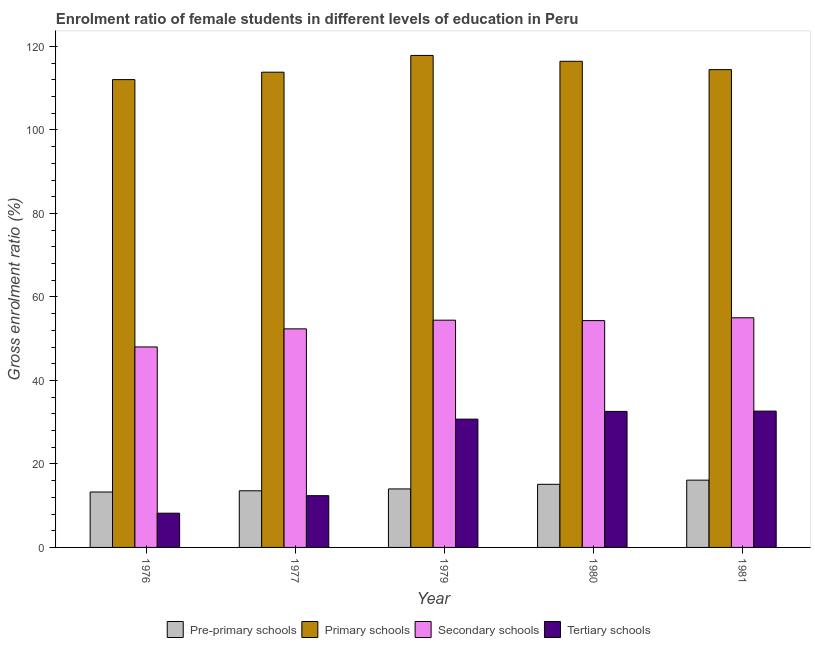How many different coloured bars are there?
Offer a terse response. 4. How many bars are there on the 4th tick from the left?
Provide a succinct answer. 4. What is the label of the 3rd group of bars from the left?
Offer a terse response. 1979. In how many cases, is the number of bars for a given year not equal to the number of legend labels?
Provide a short and direct response. 0. What is the gross enrolment ratio(male) in pre-primary schools in 1980?
Your response must be concise. 15.12. Across all years, what is the maximum gross enrolment ratio(male) in tertiary schools?
Offer a terse response. 32.65. Across all years, what is the minimum gross enrolment ratio(male) in secondary schools?
Your answer should be very brief. 48.02. In which year was the gross enrolment ratio(male) in tertiary schools maximum?
Offer a terse response. 1981. In which year was the gross enrolment ratio(male) in secondary schools minimum?
Make the answer very short. 1976. What is the total gross enrolment ratio(male) in secondary schools in the graph?
Provide a succinct answer. 264.13. What is the difference between the gross enrolment ratio(male) in secondary schools in 1979 and that in 1980?
Ensure brevity in your answer.  0.1. What is the difference between the gross enrolment ratio(male) in secondary schools in 1976 and the gross enrolment ratio(male) in primary schools in 1980?
Your answer should be compact. -6.31. What is the average gross enrolment ratio(male) in pre-primary schools per year?
Offer a terse response. 14.42. In the year 1976, what is the difference between the gross enrolment ratio(male) in tertiary schools and gross enrolment ratio(male) in pre-primary schools?
Give a very brief answer. 0. What is the ratio of the gross enrolment ratio(male) in primary schools in 1976 to that in 1980?
Offer a terse response. 0.96. Is the gross enrolment ratio(male) in primary schools in 1976 less than that in 1981?
Provide a short and direct response. Yes. Is the difference between the gross enrolment ratio(male) in pre-primary schools in 1979 and 1980 greater than the difference between the gross enrolment ratio(male) in secondary schools in 1979 and 1980?
Make the answer very short. No. What is the difference between the highest and the second highest gross enrolment ratio(male) in secondary schools?
Make the answer very short. 0.57. What is the difference between the highest and the lowest gross enrolment ratio(male) in secondary schools?
Offer a terse response. 6.98. Is it the case that in every year, the sum of the gross enrolment ratio(male) in tertiary schools and gross enrolment ratio(male) in pre-primary schools is greater than the sum of gross enrolment ratio(male) in secondary schools and gross enrolment ratio(male) in primary schools?
Ensure brevity in your answer.  No. What does the 1st bar from the left in 1979 represents?
Your answer should be compact. Pre-primary schools. What does the 3rd bar from the right in 1977 represents?
Your answer should be compact. Primary schools. Is it the case that in every year, the sum of the gross enrolment ratio(male) in pre-primary schools and gross enrolment ratio(male) in primary schools is greater than the gross enrolment ratio(male) in secondary schools?
Your response must be concise. Yes. How many bars are there?
Keep it short and to the point. 20. Are all the bars in the graph horizontal?
Make the answer very short. No. What is the difference between two consecutive major ticks on the Y-axis?
Offer a terse response. 20. Does the graph contain any zero values?
Give a very brief answer. No. What is the title of the graph?
Ensure brevity in your answer.  Enrolment ratio of female students in different levels of education in Peru. What is the label or title of the X-axis?
Your answer should be very brief. Year. What is the Gross enrolment ratio (%) in Pre-primary schools in 1976?
Provide a succinct answer. 13.27. What is the Gross enrolment ratio (%) in Primary schools in 1976?
Ensure brevity in your answer.  112.05. What is the Gross enrolment ratio (%) in Secondary schools in 1976?
Offer a very short reply. 48.02. What is the Gross enrolment ratio (%) in Tertiary schools in 1976?
Offer a very short reply. 8.2. What is the Gross enrolment ratio (%) of Pre-primary schools in 1977?
Offer a very short reply. 13.57. What is the Gross enrolment ratio (%) in Primary schools in 1977?
Provide a succinct answer. 113.82. What is the Gross enrolment ratio (%) of Secondary schools in 1977?
Ensure brevity in your answer.  52.35. What is the Gross enrolment ratio (%) in Tertiary schools in 1977?
Ensure brevity in your answer.  12.4. What is the Gross enrolment ratio (%) of Pre-primary schools in 1979?
Ensure brevity in your answer.  14.01. What is the Gross enrolment ratio (%) of Primary schools in 1979?
Your answer should be very brief. 117.84. What is the Gross enrolment ratio (%) of Secondary schools in 1979?
Keep it short and to the point. 54.43. What is the Gross enrolment ratio (%) in Tertiary schools in 1979?
Offer a very short reply. 30.73. What is the Gross enrolment ratio (%) in Pre-primary schools in 1980?
Offer a very short reply. 15.12. What is the Gross enrolment ratio (%) in Primary schools in 1980?
Provide a short and direct response. 116.44. What is the Gross enrolment ratio (%) of Secondary schools in 1980?
Your answer should be compact. 54.33. What is the Gross enrolment ratio (%) in Tertiary schools in 1980?
Offer a very short reply. 32.58. What is the Gross enrolment ratio (%) in Pre-primary schools in 1981?
Keep it short and to the point. 16.11. What is the Gross enrolment ratio (%) in Primary schools in 1981?
Your answer should be compact. 114.44. What is the Gross enrolment ratio (%) of Secondary schools in 1981?
Your answer should be compact. 55. What is the Gross enrolment ratio (%) of Tertiary schools in 1981?
Offer a very short reply. 32.65. Across all years, what is the maximum Gross enrolment ratio (%) of Pre-primary schools?
Offer a very short reply. 16.11. Across all years, what is the maximum Gross enrolment ratio (%) in Primary schools?
Your answer should be very brief. 117.84. Across all years, what is the maximum Gross enrolment ratio (%) in Secondary schools?
Ensure brevity in your answer.  55. Across all years, what is the maximum Gross enrolment ratio (%) of Tertiary schools?
Provide a succinct answer. 32.65. Across all years, what is the minimum Gross enrolment ratio (%) in Pre-primary schools?
Ensure brevity in your answer.  13.27. Across all years, what is the minimum Gross enrolment ratio (%) in Primary schools?
Make the answer very short. 112.05. Across all years, what is the minimum Gross enrolment ratio (%) in Secondary schools?
Provide a succinct answer. 48.02. Across all years, what is the minimum Gross enrolment ratio (%) of Tertiary schools?
Make the answer very short. 8.2. What is the total Gross enrolment ratio (%) of Pre-primary schools in the graph?
Your answer should be compact. 72.08. What is the total Gross enrolment ratio (%) in Primary schools in the graph?
Ensure brevity in your answer.  574.59. What is the total Gross enrolment ratio (%) of Secondary schools in the graph?
Your response must be concise. 264.13. What is the total Gross enrolment ratio (%) in Tertiary schools in the graph?
Give a very brief answer. 116.55. What is the difference between the Gross enrolment ratio (%) in Pre-primary schools in 1976 and that in 1977?
Your answer should be very brief. -0.29. What is the difference between the Gross enrolment ratio (%) of Primary schools in 1976 and that in 1977?
Offer a very short reply. -1.77. What is the difference between the Gross enrolment ratio (%) in Secondary schools in 1976 and that in 1977?
Your answer should be compact. -4.33. What is the difference between the Gross enrolment ratio (%) in Tertiary schools in 1976 and that in 1977?
Provide a succinct answer. -4.2. What is the difference between the Gross enrolment ratio (%) of Pre-primary schools in 1976 and that in 1979?
Your answer should be compact. -0.74. What is the difference between the Gross enrolment ratio (%) in Primary schools in 1976 and that in 1979?
Give a very brief answer. -5.79. What is the difference between the Gross enrolment ratio (%) of Secondary schools in 1976 and that in 1979?
Give a very brief answer. -6.41. What is the difference between the Gross enrolment ratio (%) of Tertiary schools in 1976 and that in 1979?
Your response must be concise. -22.53. What is the difference between the Gross enrolment ratio (%) in Pre-primary schools in 1976 and that in 1980?
Your response must be concise. -1.85. What is the difference between the Gross enrolment ratio (%) of Primary schools in 1976 and that in 1980?
Your answer should be very brief. -4.39. What is the difference between the Gross enrolment ratio (%) in Secondary schools in 1976 and that in 1980?
Your response must be concise. -6.31. What is the difference between the Gross enrolment ratio (%) of Tertiary schools in 1976 and that in 1980?
Give a very brief answer. -24.38. What is the difference between the Gross enrolment ratio (%) of Pre-primary schools in 1976 and that in 1981?
Offer a terse response. -2.84. What is the difference between the Gross enrolment ratio (%) of Primary schools in 1976 and that in 1981?
Ensure brevity in your answer.  -2.39. What is the difference between the Gross enrolment ratio (%) in Secondary schools in 1976 and that in 1981?
Keep it short and to the point. -6.98. What is the difference between the Gross enrolment ratio (%) in Tertiary schools in 1976 and that in 1981?
Ensure brevity in your answer.  -24.45. What is the difference between the Gross enrolment ratio (%) in Pre-primary schools in 1977 and that in 1979?
Provide a succinct answer. -0.44. What is the difference between the Gross enrolment ratio (%) of Primary schools in 1977 and that in 1979?
Provide a short and direct response. -4.02. What is the difference between the Gross enrolment ratio (%) of Secondary schools in 1977 and that in 1979?
Your answer should be very brief. -2.08. What is the difference between the Gross enrolment ratio (%) in Tertiary schools in 1977 and that in 1979?
Your answer should be compact. -18.33. What is the difference between the Gross enrolment ratio (%) of Pre-primary schools in 1977 and that in 1980?
Make the answer very short. -1.55. What is the difference between the Gross enrolment ratio (%) of Primary schools in 1977 and that in 1980?
Give a very brief answer. -2.61. What is the difference between the Gross enrolment ratio (%) of Secondary schools in 1977 and that in 1980?
Provide a short and direct response. -1.97. What is the difference between the Gross enrolment ratio (%) of Tertiary schools in 1977 and that in 1980?
Your answer should be very brief. -20.18. What is the difference between the Gross enrolment ratio (%) of Pre-primary schools in 1977 and that in 1981?
Give a very brief answer. -2.55. What is the difference between the Gross enrolment ratio (%) of Primary schools in 1977 and that in 1981?
Provide a succinct answer. -0.62. What is the difference between the Gross enrolment ratio (%) of Secondary schools in 1977 and that in 1981?
Your response must be concise. -2.65. What is the difference between the Gross enrolment ratio (%) of Tertiary schools in 1977 and that in 1981?
Offer a very short reply. -20.25. What is the difference between the Gross enrolment ratio (%) in Pre-primary schools in 1979 and that in 1980?
Your answer should be compact. -1.11. What is the difference between the Gross enrolment ratio (%) in Primary schools in 1979 and that in 1980?
Your answer should be compact. 1.4. What is the difference between the Gross enrolment ratio (%) in Secondary schools in 1979 and that in 1980?
Offer a terse response. 0.1. What is the difference between the Gross enrolment ratio (%) in Tertiary schools in 1979 and that in 1980?
Provide a short and direct response. -1.85. What is the difference between the Gross enrolment ratio (%) in Pre-primary schools in 1979 and that in 1981?
Make the answer very short. -2.1. What is the difference between the Gross enrolment ratio (%) of Primary schools in 1979 and that in 1981?
Provide a short and direct response. 3.4. What is the difference between the Gross enrolment ratio (%) of Secondary schools in 1979 and that in 1981?
Offer a very short reply. -0.57. What is the difference between the Gross enrolment ratio (%) of Tertiary schools in 1979 and that in 1981?
Keep it short and to the point. -1.92. What is the difference between the Gross enrolment ratio (%) of Pre-primary schools in 1980 and that in 1981?
Offer a very short reply. -1. What is the difference between the Gross enrolment ratio (%) in Primary schools in 1980 and that in 1981?
Offer a terse response. 2. What is the difference between the Gross enrolment ratio (%) in Secondary schools in 1980 and that in 1981?
Your response must be concise. -0.67. What is the difference between the Gross enrolment ratio (%) in Tertiary schools in 1980 and that in 1981?
Offer a terse response. -0.07. What is the difference between the Gross enrolment ratio (%) in Pre-primary schools in 1976 and the Gross enrolment ratio (%) in Primary schools in 1977?
Your answer should be compact. -100.55. What is the difference between the Gross enrolment ratio (%) in Pre-primary schools in 1976 and the Gross enrolment ratio (%) in Secondary schools in 1977?
Offer a terse response. -39.08. What is the difference between the Gross enrolment ratio (%) of Pre-primary schools in 1976 and the Gross enrolment ratio (%) of Tertiary schools in 1977?
Keep it short and to the point. 0.88. What is the difference between the Gross enrolment ratio (%) of Primary schools in 1976 and the Gross enrolment ratio (%) of Secondary schools in 1977?
Make the answer very short. 59.7. What is the difference between the Gross enrolment ratio (%) of Primary schools in 1976 and the Gross enrolment ratio (%) of Tertiary schools in 1977?
Your response must be concise. 99.65. What is the difference between the Gross enrolment ratio (%) of Secondary schools in 1976 and the Gross enrolment ratio (%) of Tertiary schools in 1977?
Your answer should be very brief. 35.62. What is the difference between the Gross enrolment ratio (%) in Pre-primary schools in 1976 and the Gross enrolment ratio (%) in Primary schools in 1979?
Offer a terse response. -104.57. What is the difference between the Gross enrolment ratio (%) in Pre-primary schools in 1976 and the Gross enrolment ratio (%) in Secondary schools in 1979?
Keep it short and to the point. -41.16. What is the difference between the Gross enrolment ratio (%) in Pre-primary schools in 1976 and the Gross enrolment ratio (%) in Tertiary schools in 1979?
Give a very brief answer. -17.45. What is the difference between the Gross enrolment ratio (%) in Primary schools in 1976 and the Gross enrolment ratio (%) in Secondary schools in 1979?
Keep it short and to the point. 57.62. What is the difference between the Gross enrolment ratio (%) in Primary schools in 1976 and the Gross enrolment ratio (%) in Tertiary schools in 1979?
Offer a terse response. 81.32. What is the difference between the Gross enrolment ratio (%) of Secondary schools in 1976 and the Gross enrolment ratio (%) of Tertiary schools in 1979?
Offer a terse response. 17.3. What is the difference between the Gross enrolment ratio (%) of Pre-primary schools in 1976 and the Gross enrolment ratio (%) of Primary schools in 1980?
Your answer should be very brief. -103.16. What is the difference between the Gross enrolment ratio (%) of Pre-primary schools in 1976 and the Gross enrolment ratio (%) of Secondary schools in 1980?
Offer a very short reply. -41.05. What is the difference between the Gross enrolment ratio (%) of Pre-primary schools in 1976 and the Gross enrolment ratio (%) of Tertiary schools in 1980?
Your answer should be compact. -19.3. What is the difference between the Gross enrolment ratio (%) of Primary schools in 1976 and the Gross enrolment ratio (%) of Secondary schools in 1980?
Provide a short and direct response. 57.72. What is the difference between the Gross enrolment ratio (%) of Primary schools in 1976 and the Gross enrolment ratio (%) of Tertiary schools in 1980?
Keep it short and to the point. 79.47. What is the difference between the Gross enrolment ratio (%) in Secondary schools in 1976 and the Gross enrolment ratio (%) in Tertiary schools in 1980?
Keep it short and to the point. 15.45. What is the difference between the Gross enrolment ratio (%) in Pre-primary schools in 1976 and the Gross enrolment ratio (%) in Primary schools in 1981?
Provide a short and direct response. -101.17. What is the difference between the Gross enrolment ratio (%) of Pre-primary schools in 1976 and the Gross enrolment ratio (%) of Secondary schools in 1981?
Offer a very short reply. -41.73. What is the difference between the Gross enrolment ratio (%) in Pre-primary schools in 1976 and the Gross enrolment ratio (%) in Tertiary schools in 1981?
Provide a short and direct response. -19.38. What is the difference between the Gross enrolment ratio (%) of Primary schools in 1976 and the Gross enrolment ratio (%) of Secondary schools in 1981?
Ensure brevity in your answer.  57.05. What is the difference between the Gross enrolment ratio (%) in Primary schools in 1976 and the Gross enrolment ratio (%) in Tertiary schools in 1981?
Offer a very short reply. 79.4. What is the difference between the Gross enrolment ratio (%) of Secondary schools in 1976 and the Gross enrolment ratio (%) of Tertiary schools in 1981?
Ensure brevity in your answer.  15.37. What is the difference between the Gross enrolment ratio (%) in Pre-primary schools in 1977 and the Gross enrolment ratio (%) in Primary schools in 1979?
Provide a short and direct response. -104.27. What is the difference between the Gross enrolment ratio (%) in Pre-primary schools in 1977 and the Gross enrolment ratio (%) in Secondary schools in 1979?
Keep it short and to the point. -40.86. What is the difference between the Gross enrolment ratio (%) in Pre-primary schools in 1977 and the Gross enrolment ratio (%) in Tertiary schools in 1979?
Give a very brief answer. -17.16. What is the difference between the Gross enrolment ratio (%) in Primary schools in 1977 and the Gross enrolment ratio (%) in Secondary schools in 1979?
Make the answer very short. 59.39. What is the difference between the Gross enrolment ratio (%) in Primary schools in 1977 and the Gross enrolment ratio (%) in Tertiary schools in 1979?
Give a very brief answer. 83.1. What is the difference between the Gross enrolment ratio (%) in Secondary schools in 1977 and the Gross enrolment ratio (%) in Tertiary schools in 1979?
Give a very brief answer. 21.63. What is the difference between the Gross enrolment ratio (%) in Pre-primary schools in 1977 and the Gross enrolment ratio (%) in Primary schools in 1980?
Offer a very short reply. -102.87. What is the difference between the Gross enrolment ratio (%) in Pre-primary schools in 1977 and the Gross enrolment ratio (%) in Secondary schools in 1980?
Your response must be concise. -40.76. What is the difference between the Gross enrolment ratio (%) of Pre-primary schools in 1977 and the Gross enrolment ratio (%) of Tertiary schools in 1980?
Offer a terse response. -19.01. What is the difference between the Gross enrolment ratio (%) of Primary schools in 1977 and the Gross enrolment ratio (%) of Secondary schools in 1980?
Provide a short and direct response. 59.5. What is the difference between the Gross enrolment ratio (%) of Primary schools in 1977 and the Gross enrolment ratio (%) of Tertiary schools in 1980?
Keep it short and to the point. 81.25. What is the difference between the Gross enrolment ratio (%) in Secondary schools in 1977 and the Gross enrolment ratio (%) in Tertiary schools in 1980?
Your answer should be compact. 19.78. What is the difference between the Gross enrolment ratio (%) of Pre-primary schools in 1977 and the Gross enrolment ratio (%) of Primary schools in 1981?
Keep it short and to the point. -100.87. What is the difference between the Gross enrolment ratio (%) in Pre-primary schools in 1977 and the Gross enrolment ratio (%) in Secondary schools in 1981?
Offer a terse response. -41.43. What is the difference between the Gross enrolment ratio (%) in Pre-primary schools in 1977 and the Gross enrolment ratio (%) in Tertiary schools in 1981?
Offer a very short reply. -19.08. What is the difference between the Gross enrolment ratio (%) in Primary schools in 1977 and the Gross enrolment ratio (%) in Secondary schools in 1981?
Keep it short and to the point. 58.82. What is the difference between the Gross enrolment ratio (%) in Primary schools in 1977 and the Gross enrolment ratio (%) in Tertiary schools in 1981?
Give a very brief answer. 81.17. What is the difference between the Gross enrolment ratio (%) of Secondary schools in 1977 and the Gross enrolment ratio (%) of Tertiary schools in 1981?
Your answer should be compact. 19.7. What is the difference between the Gross enrolment ratio (%) in Pre-primary schools in 1979 and the Gross enrolment ratio (%) in Primary schools in 1980?
Your answer should be compact. -102.43. What is the difference between the Gross enrolment ratio (%) in Pre-primary schools in 1979 and the Gross enrolment ratio (%) in Secondary schools in 1980?
Make the answer very short. -40.32. What is the difference between the Gross enrolment ratio (%) of Pre-primary schools in 1979 and the Gross enrolment ratio (%) of Tertiary schools in 1980?
Your answer should be very brief. -18.56. What is the difference between the Gross enrolment ratio (%) of Primary schools in 1979 and the Gross enrolment ratio (%) of Secondary schools in 1980?
Ensure brevity in your answer.  63.52. What is the difference between the Gross enrolment ratio (%) in Primary schools in 1979 and the Gross enrolment ratio (%) in Tertiary schools in 1980?
Offer a terse response. 85.27. What is the difference between the Gross enrolment ratio (%) of Secondary schools in 1979 and the Gross enrolment ratio (%) of Tertiary schools in 1980?
Make the answer very short. 21.85. What is the difference between the Gross enrolment ratio (%) of Pre-primary schools in 1979 and the Gross enrolment ratio (%) of Primary schools in 1981?
Ensure brevity in your answer.  -100.43. What is the difference between the Gross enrolment ratio (%) of Pre-primary schools in 1979 and the Gross enrolment ratio (%) of Secondary schools in 1981?
Provide a short and direct response. -40.99. What is the difference between the Gross enrolment ratio (%) of Pre-primary schools in 1979 and the Gross enrolment ratio (%) of Tertiary schools in 1981?
Your response must be concise. -18.64. What is the difference between the Gross enrolment ratio (%) of Primary schools in 1979 and the Gross enrolment ratio (%) of Secondary schools in 1981?
Provide a succinct answer. 62.84. What is the difference between the Gross enrolment ratio (%) of Primary schools in 1979 and the Gross enrolment ratio (%) of Tertiary schools in 1981?
Ensure brevity in your answer.  85.19. What is the difference between the Gross enrolment ratio (%) in Secondary schools in 1979 and the Gross enrolment ratio (%) in Tertiary schools in 1981?
Provide a short and direct response. 21.78. What is the difference between the Gross enrolment ratio (%) of Pre-primary schools in 1980 and the Gross enrolment ratio (%) of Primary schools in 1981?
Make the answer very short. -99.32. What is the difference between the Gross enrolment ratio (%) of Pre-primary schools in 1980 and the Gross enrolment ratio (%) of Secondary schools in 1981?
Ensure brevity in your answer.  -39.88. What is the difference between the Gross enrolment ratio (%) of Pre-primary schools in 1980 and the Gross enrolment ratio (%) of Tertiary schools in 1981?
Offer a very short reply. -17.53. What is the difference between the Gross enrolment ratio (%) in Primary schools in 1980 and the Gross enrolment ratio (%) in Secondary schools in 1981?
Provide a short and direct response. 61.44. What is the difference between the Gross enrolment ratio (%) of Primary schools in 1980 and the Gross enrolment ratio (%) of Tertiary schools in 1981?
Provide a succinct answer. 83.79. What is the difference between the Gross enrolment ratio (%) in Secondary schools in 1980 and the Gross enrolment ratio (%) in Tertiary schools in 1981?
Your answer should be very brief. 21.68. What is the average Gross enrolment ratio (%) of Pre-primary schools per year?
Provide a succinct answer. 14.42. What is the average Gross enrolment ratio (%) of Primary schools per year?
Provide a succinct answer. 114.92. What is the average Gross enrolment ratio (%) of Secondary schools per year?
Your answer should be compact. 52.83. What is the average Gross enrolment ratio (%) of Tertiary schools per year?
Provide a short and direct response. 23.31. In the year 1976, what is the difference between the Gross enrolment ratio (%) in Pre-primary schools and Gross enrolment ratio (%) in Primary schools?
Your response must be concise. -98.78. In the year 1976, what is the difference between the Gross enrolment ratio (%) in Pre-primary schools and Gross enrolment ratio (%) in Secondary schools?
Offer a terse response. -34.75. In the year 1976, what is the difference between the Gross enrolment ratio (%) in Pre-primary schools and Gross enrolment ratio (%) in Tertiary schools?
Provide a short and direct response. 5.07. In the year 1976, what is the difference between the Gross enrolment ratio (%) in Primary schools and Gross enrolment ratio (%) in Secondary schools?
Your answer should be very brief. 64.03. In the year 1976, what is the difference between the Gross enrolment ratio (%) in Primary schools and Gross enrolment ratio (%) in Tertiary schools?
Give a very brief answer. 103.85. In the year 1976, what is the difference between the Gross enrolment ratio (%) of Secondary schools and Gross enrolment ratio (%) of Tertiary schools?
Offer a terse response. 39.82. In the year 1977, what is the difference between the Gross enrolment ratio (%) in Pre-primary schools and Gross enrolment ratio (%) in Primary schools?
Your response must be concise. -100.26. In the year 1977, what is the difference between the Gross enrolment ratio (%) of Pre-primary schools and Gross enrolment ratio (%) of Secondary schools?
Your response must be concise. -38.79. In the year 1977, what is the difference between the Gross enrolment ratio (%) in Pre-primary schools and Gross enrolment ratio (%) in Tertiary schools?
Ensure brevity in your answer.  1.17. In the year 1977, what is the difference between the Gross enrolment ratio (%) in Primary schools and Gross enrolment ratio (%) in Secondary schools?
Your answer should be compact. 61.47. In the year 1977, what is the difference between the Gross enrolment ratio (%) of Primary schools and Gross enrolment ratio (%) of Tertiary schools?
Keep it short and to the point. 101.43. In the year 1977, what is the difference between the Gross enrolment ratio (%) of Secondary schools and Gross enrolment ratio (%) of Tertiary schools?
Offer a terse response. 39.96. In the year 1979, what is the difference between the Gross enrolment ratio (%) of Pre-primary schools and Gross enrolment ratio (%) of Primary schools?
Provide a succinct answer. -103.83. In the year 1979, what is the difference between the Gross enrolment ratio (%) in Pre-primary schools and Gross enrolment ratio (%) in Secondary schools?
Provide a succinct answer. -40.42. In the year 1979, what is the difference between the Gross enrolment ratio (%) of Pre-primary schools and Gross enrolment ratio (%) of Tertiary schools?
Offer a terse response. -16.72. In the year 1979, what is the difference between the Gross enrolment ratio (%) of Primary schools and Gross enrolment ratio (%) of Secondary schools?
Your answer should be compact. 63.41. In the year 1979, what is the difference between the Gross enrolment ratio (%) in Primary schools and Gross enrolment ratio (%) in Tertiary schools?
Your answer should be compact. 87.12. In the year 1979, what is the difference between the Gross enrolment ratio (%) in Secondary schools and Gross enrolment ratio (%) in Tertiary schools?
Give a very brief answer. 23.7. In the year 1980, what is the difference between the Gross enrolment ratio (%) in Pre-primary schools and Gross enrolment ratio (%) in Primary schools?
Ensure brevity in your answer.  -101.32. In the year 1980, what is the difference between the Gross enrolment ratio (%) of Pre-primary schools and Gross enrolment ratio (%) of Secondary schools?
Your response must be concise. -39.21. In the year 1980, what is the difference between the Gross enrolment ratio (%) in Pre-primary schools and Gross enrolment ratio (%) in Tertiary schools?
Provide a short and direct response. -17.46. In the year 1980, what is the difference between the Gross enrolment ratio (%) in Primary schools and Gross enrolment ratio (%) in Secondary schools?
Keep it short and to the point. 62.11. In the year 1980, what is the difference between the Gross enrolment ratio (%) of Primary schools and Gross enrolment ratio (%) of Tertiary schools?
Keep it short and to the point. 83.86. In the year 1980, what is the difference between the Gross enrolment ratio (%) of Secondary schools and Gross enrolment ratio (%) of Tertiary schools?
Provide a short and direct response. 21.75. In the year 1981, what is the difference between the Gross enrolment ratio (%) of Pre-primary schools and Gross enrolment ratio (%) of Primary schools?
Offer a very short reply. -98.33. In the year 1981, what is the difference between the Gross enrolment ratio (%) of Pre-primary schools and Gross enrolment ratio (%) of Secondary schools?
Make the answer very short. -38.89. In the year 1981, what is the difference between the Gross enrolment ratio (%) in Pre-primary schools and Gross enrolment ratio (%) in Tertiary schools?
Your answer should be compact. -16.54. In the year 1981, what is the difference between the Gross enrolment ratio (%) in Primary schools and Gross enrolment ratio (%) in Secondary schools?
Ensure brevity in your answer.  59.44. In the year 1981, what is the difference between the Gross enrolment ratio (%) in Primary schools and Gross enrolment ratio (%) in Tertiary schools?
Keep it short and to the point. 81.79. In the year 1981, what is the difference between the Gross enrolment ratio (%) in Secondary schools and Gross enrolment ratio (%) in Tertiary schools?
Ensure brevity in your answer.  22.35. What is the ratio of the Gross enrolment ratio (%) of Pre-primary schools in 1976 to that in 1977?
Your response must be concise. 0.98. What is the ratio of the Gross enrolment ratio (%) of Primary schools in 1976 to that in 1977?
Your response must be concise. 0.98. What is the ratio of the Gross enrolment ratio (%) of Secondary schools in 1976 to that in 1977?
Your answer should be very brief. 0.92. What is the ratio of the Gross enrolment ratio (%) of Tertiary schools in 1976 to that in 1977?
Your answer should be compact. 0.66. What is the ratio of the Gross enrolment ratio (%) of Pre-primary schools in 1976 to that in 1979?
Provide a succinct answer. 0.95. What is the ratio of the Gross enrolment ratio (%) of Primary schools in 1976 to that in 1979?
Ensure brevity in your answer.  0.95. What is the ratio of the Gross enrolment ratio (%) in Secondary schools in 1976 to that in 1979?
Offer a very short reply. 0.88. What is the ratio of the Gross enrolment ratio (%) in Tertiary schools in 1976 to that in 1979?
Your answer should be compact. 0.27. What is the ratio of the Gross enrolment ratio (%) in Pre-primary schools in 1976 to that in 1980?
Ensure brevity in your answer.  0.88. What is the ratio of the Gross enrolment ratio (%) in Primary schools in 1976 to that in 1980?
Offer a terse response. 0.96. What is the ratio of the Gross enrolment ratio (%) in Secondary schools in 1976 to that in 1980?
Keep it short and to the point. 0.88. What is the ratio of the Gross enrolment ratio (%) of Tertiary schools in 1976 to that in 1980?
Keep it short and to the point. 0.25. What is the ratio of the Gross enrolment ratio (%) of Pre-primary schools in 1976 to that in 1981?
Make the answer very short. 0.82. What is the ratio of the Gross enrolment ratio (%) in Primary schools in 1976 to that in 1981?
Provide a short and direct response. 0.98. What is the ratio of the Gross enrolment ratio (%) of Secondary schools in 1976 to that in 1981?
Give a very brief answer. 0.87. What is the ratio of the Gross enrolment ratio (%) of Tertiary schools in 1976 to that in 1981?
Keep it short and to the point. 0.25. What is the ratio of the Gross enrolment ratio (%) of Pre-primary schools in 1977 to that in 1979?
Give a very brief answer. 0.97. What is the ratio of the Gross enrolment ratio (%) in Primary schools in 1977 to that in 1979?
Give a very brief answer. 0.97. What is the ratio of the Gross enrolment ratio (%) in Secondary schools in 1977 to that in 1979?
Make the answer very short. 0.96. What is the ratio of the Gross enrolment ratio (%) in Tertiary schools in 1977 to that in 1979?
Offer a very short reply. 0.4. What is the ratio of the Gross enrolment ratio (%) of Pre-primary schools in 1977 to that in 1980?
Your answer should be compact. 0.9. What is the ratio of the Gross enrolment ratio (%) in Primary schools in 1977 to that in 1980?
Your answer should be very brief. 0.98. What is the ratio of the Gross enrolment ratio (%) in Secondary schools in 1977 to that in 1980?
Provide a short and direct response. 0.96. What is the ratio of the Gross enrolment ratio (%) of Tertiary schools in 1977 to that in 1980?
Give a very brief answer. 0.38. What is the ratio of the Gross enrolment ratio (%) in Pre-primary schools in 1977 to that in 1981?
Make the answer very short. 0.84. What is the ratio of the Gross enrolment ratio (%) in Primary schools in 1977 to that in 1981?
Your answer should be compact. 0.99. What is the ratio of the Gross enrolment ratio (%) in Secondary schools in 1977 to that in 1981?
Offer a terse response. 0.95. What is the ratio of the Gross enrolment ratio (%) of Tertiary schools in 1977 to that in 1981?
Give a very brief answer. 0.38. What is the ratio of the Gross enrolment ratio (%) in Pre-primary schools in 1979 to that in 1980?
Your answer should be compact. 0.93. What is the ratio of the Gross enrolment ratio (%) of Primary schools in 1979 to that in 1980?
Provide a succinct answer. 1.01. What is the ratio of the Gross enrolment ratio (%) in Secondary schools in 1979 to that in 1980?
Your answer should be compact. 1. What is the ratio of the Gross enrolment ratio (%) in Tertiary schools in 1979 to that in 1980?
Give a very brief answer. 0.94. What is the ratio of the Gross enrolment ratio (%) of Pre-primary schools in 1979 to that in 1981?
Make the answer very short. 0.87. What is the ratio of the Gross enrolment ratio (%) in Primary schools in 1979 to that in 1981?
Your answer should be compact. 1.03. What is the ratio of the Gross enrolment ratio (%) in Secondary schools in 1979 to that in 1981?
Your answer should be compact. 0.99. What is the ratio of the Gross enrolment ratio (%) of Tertiary schools in 1979 to that in 1981?
Your response must be concise. 0.94. What is the ratio of the Gross enrolment ratio (%) in Pre-primary schools in 1980 to that in 1981?
Provide a short and direct response. 0.94. What is the ratio of the Gross enrolment ratio (%) in Primary schools in 1980 to that in 1981?
Provide a short and direct response. 1.02. What is the ratio of the Gross enrolment ratio (%) in Secondary schools in 1980 to that in 1981?
Provide a short and direct response. 0.99. What is the difference between the highest and the second highest Gross enrolment ratio (%) in Pre-primary schools?
Ensure brevity in your answer.  1. What is the difference between the highest and the second highest Gross enrolment ratio (%) in Primary schools?
Provide a short and direct response. 1.4. What is the difference between the highest and the second highest Gross enrolment ratio (%) of Secondary schools?
Your answer should be compact. 0.57. What is the difference between the highest and the second highest Gross enrolment ratio (%) in Tertiary schools?
Your response must be concise. 0.07. What is the difference between the highest and the lowest Gross enrolment ratio (%) of Pre-primary schools?
Make the answer very short. 2.84. What is the difference between the highest and the lowest Gross enrolment ratio (%) of Primary schools?
Provide a succinct answer. 5.79. What is the difference between the highest and the lowest Gross enrolment ratio (%) in Secondary schools?
Your response must be concise. 6.98. What is the difference between the highest and the lowest Gross enrolment ratio (%) of Tertiary schools?
Your response must be concise. 24.45. 